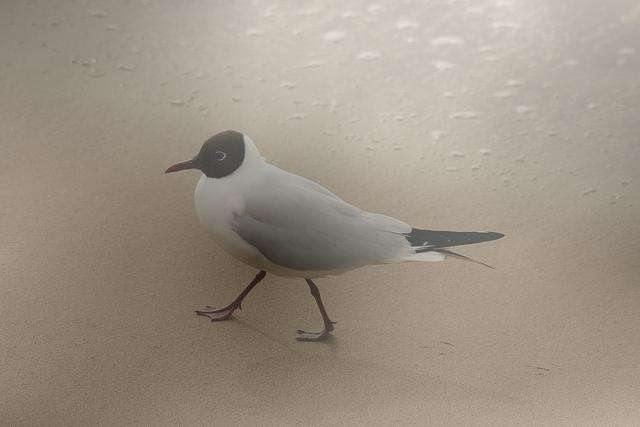What might be the mood conveyed by this image? The image conveys a tranquil and serene mood. The solitary seagull and the empty beach create a sense of peaceful solitude. The gentle lighting and the soft, wet sand add to this calming atmosphere, suggesting a quiet moment in nature. 